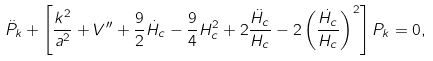Convert formula to latex. <formula><loc_0><loc_0><loc_500><loc_500>\ddot { P } _ { k } + \left [ \frac { k ^ { 2 } } { a ^ { 2 } } + V ^ { \prime \prime } + \frac { 9 } { 2 } \dot { H } _ { c } - \frac { 9 } { 4 } H ^ { 2 } _ { c } + 2 \frac { \ddot { H } _ { c } } { H _ { c } } - 2 \left ( \frac { \dot { H } _ { c } } { H _ { c } } \right ) ^ { 2 } \right ] P _ { k } = 0 ,</formula> 